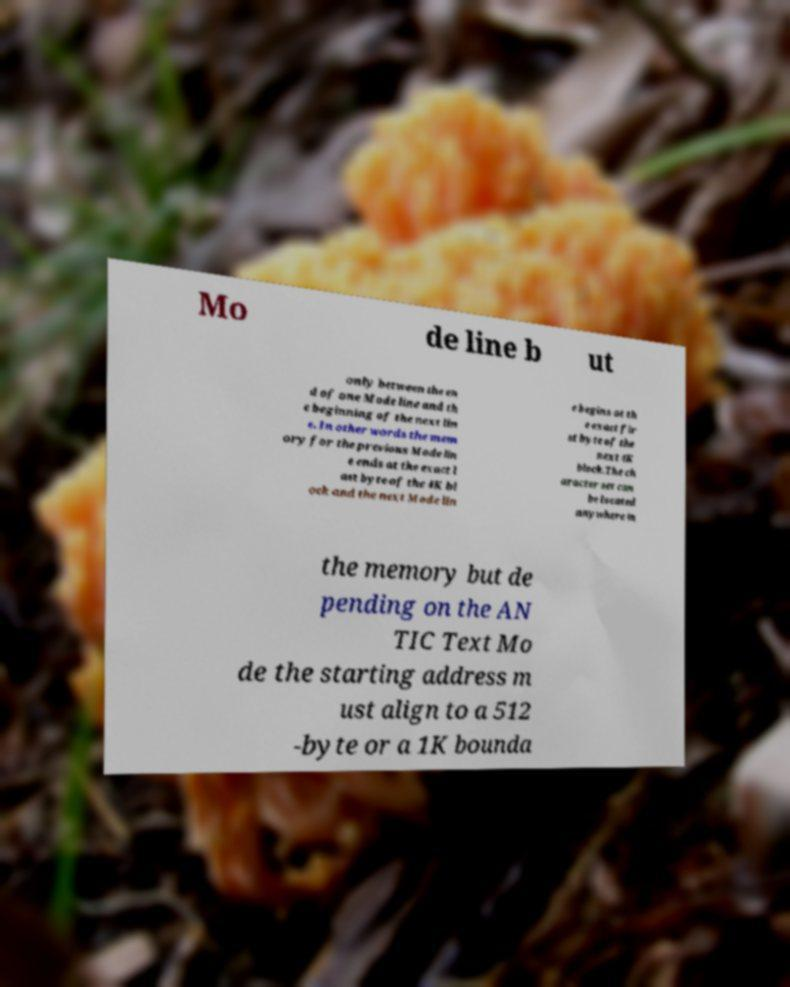Can you read and provide the text displayed in the image?This photo seems to have some interesting text. Can you extract and type it out for me? Mo de line b ut only between the en d of one Mode line and th e beginning of the next lin e. In other words the mem ory for the previous Mode lin e ends at the exact l ast byte of the 4K bl ock and the next Mode lin e begins at th e exact fir st byte of the next 4K block.The ch aracter set can be located anywhere in the memory but de pending on the AN TIC Text Mo de the starting address m ust align to a 512 -byte or a 1K bounda 